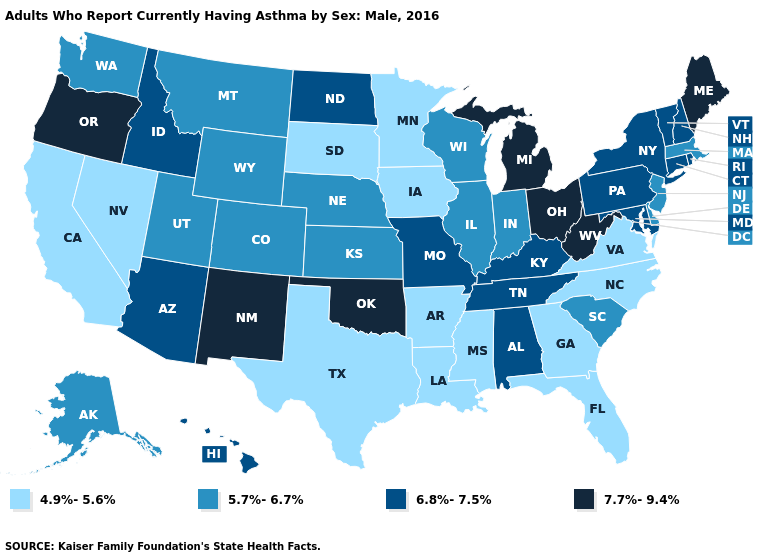Does Colorado have the lowest value in the West?
Give a very brief answer. No. What is the highest value in the USA?
Keep it brief. 7.7%-9.4%. Which states have the highest value in the USA?
Give a very brief answer. Maine, Michigan, New Mexico, Ohio, Oklahoma, Oregon, West Virginia. What is the value of Texas?
Keep it brief. 4.9%-5.6%. Does New York have the lowest value in the USA?
Keep it brief. No. Name the states that have a value in the range 4.9%-5.6%?
Be succinct. Arkansas, California, Florida, Georgia, Iowa, Louisiana, Minnesota, Mississippi, Nevada, North Carolina, South Dakota, Texas, Virginia. Does Georgia have the lowest value in the USA?
Short answer required. Yes. How many symbols are there in the legend?
Be succinct. 4. Which states have the lowest value in the Northeast?
Be succinct. Massachusetts, New Jersey. Does California have a lower value than Indiana?
Quick response, please. Yes. Which states have the highest value in the USA?
Give a very brief answer. Maine, Michigan, New Mexico, Ohio, Oklahoma, Oregon, West Virginia. Name the states that have a value in the range 6.8%-7.5%?
Concise answer only. Alabama, Arizona, Connecticut, Hawaii, Idaho, Kentucky, Maryland, Missouri, New Hampshire, New York, North Dakota, Pennsylvania, Rhode Island, Tennessee, Vermont. Which states have the lowest value in the Northeast?
Answer briefly. Massachusetts, New Jersey. What is the lowest value in the South?
Be succinct. 4.9%-5.6%. Does the first symbol in the legend represent the smallest category?
Keep it brief. Yes. 